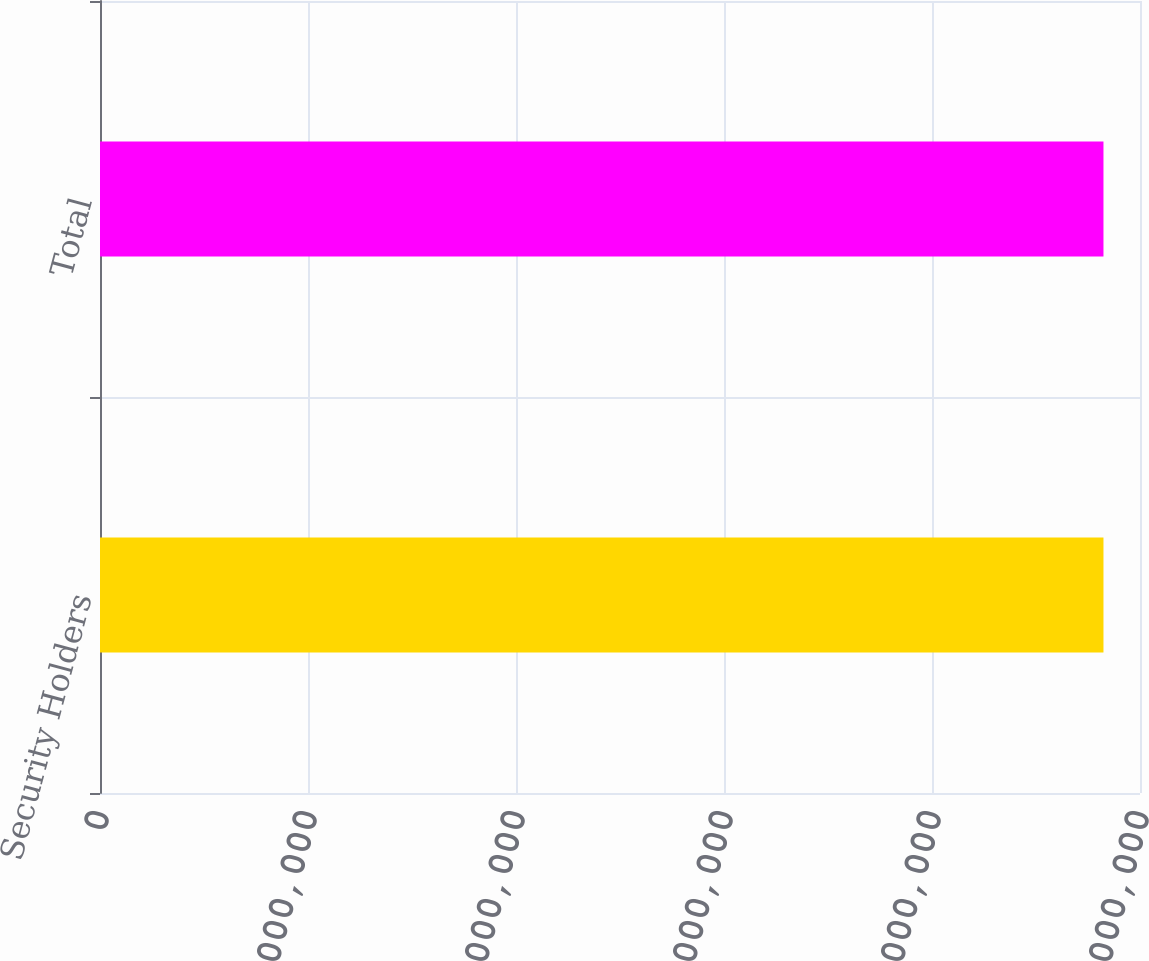Convert chart to OTSL. <chart><loc_0><loc_0><loc_500><loc_500><bar_chart><fcel>Security Holders<fcel>Total<nl><fcel>9.64877e+06<fcel>9.64877e+06<nl></chart> 